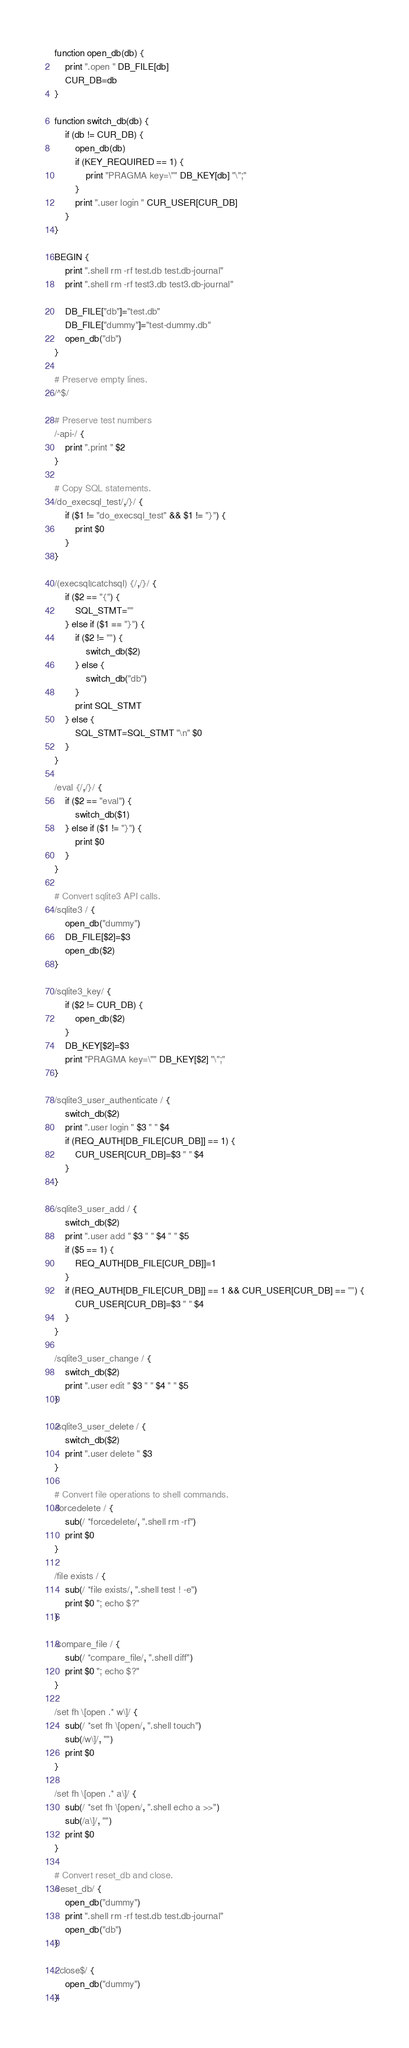<code> <loc_0><loc_0><loc_500><loc_500><_Awk_>function open_db(db) {
	print ".open " DB_FILE[db]
	CUR_DB=db
}

function switch_db(db) {
	if (db != CUR_DB) {
		open_db(db)
		if (KEY_REQUIRED == 1) {
			print "PRAGMA key=\"" DB_KEY[db] "\";"
		}
		print ".user login " CUR_USER[CUR_DB]
	}
}

BEGIN {
	print ".shell rm -rf test.db test.db-journal"
	print ".shell rm -rf test3.db test3.db-journal"

	DB_FILE["db"]="test.db"
	DB_FILE["dummy"]="test-dummy.db"
	open_db("db")
}

# Preserve empty lines.
/^$/

# Preserve test numbers
/-api-/ {
	print ".print " $2
}

# Copy SQL statements.
/do_execsql_test/,/}/ {
	if ($1 != "do_execsql_test" && $1 != "}") {
		print $0
	}
}

/(execsql|catchsql) {/,/}/ {
	if ($2 == "{") {
		SQL_STMT=""
	} else if ($1 == "}") {
		if ($2 != "") {
			switch_db($2)
		} else {
			switch_db("db")
		}
		print SQL_STMT
	} else {
		SQL_STMT=SQL_STMT "\n" $0
	}
}

/eval {/,/}/ {
	if ($2 == "eval") {
		switch_db($1)
	} else if ($1 != "}") {
		print $0
	}
}

# Convert sqlite3 API calls.
/sqlite3 / {
	open_db("dummy")
	DB_FILE[$2]=$3
	open_db($2)
}

/sqlite3_key/ {
	if ($2 != CUR_DB) {
		open_db($2)
	}
	DB_KEY[$2]=$3
	print "PRAGMA key=\"" DB_KEY[$2] "\";"
}

/sqlite3_user_authenticate / {
	switch_db($2)
	print ".user login " $3 " " $4
	if (REQ_AUTH[DB_FILE[CUR_DB]] == 1) {
		CUR_USER[CUR_DB]=$3 " " $4
	}
}

/sqlite3_user_add / {
	switch_db($2)
	print ".user add " $3 " " $4 " " $5
	if ($5 == 1) {
		REQ_AUTH[DB_FILE[CUR_DB]]=1
	}
	if (REQ_AUTH[DB_FILE[CUR_DB]] == 1 && CUR_USER[CUR_DB] == "") {
		CUR_USER[CUR_DB]=$3 " " $4
	}
}

/sqlite3_user_change / {
	switch_db($2)
	print ".user edit " $3 " " $4 " " $5
}

/sqlite3_user_delete / {
	switch_db($2)
	print ".user delete " $3
}

# Convert file operations to shell commands.
/forcedelete / {
	sub(/ *forcedelete/, ".shell rm -rf")
	print $0
}

/file exists / {
	sub(/ *file exists/, ".shell test ! -e")
	print $0 "; echo $?"
}

/compare_file / {
	sub(/ *compare_file/, ".shell diff")
	print $0 "; echo $?"
}

/set fh \[open .* w\]/ {
	sub(/ *set fh \[open/, ".shell touch")
	sub(/w\]/, "")
	print $0
}

/set fh \[open .* a\]/ {
	sub(/ *set fh \[open/, ".shell echo a >>")
	sub(/a\]/, "")
	print $0
}

# Convert reset_db and close.
/reset_db/ {
	open_db("dummy")
	print ".shell rm -rf test.db test.db-journal"
	open_db("db")
}

/ close$/ {
	open_db("dummy")
}
</code> 